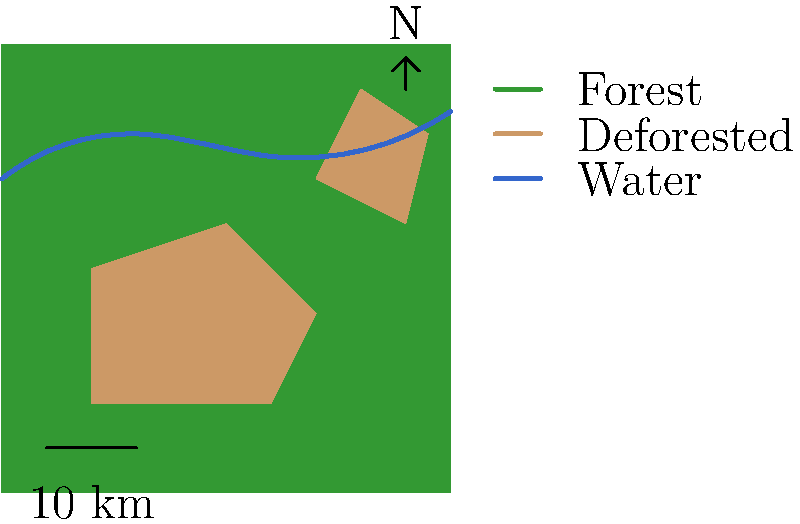Analyze the satellite imagery of a mining-affected region. What percentage of the total land area shown has been deforested due to mining activities? Round your answer to the nearest whole number. To calculate the percentage of deforested land:

1. Estimate the total area of the image:
   The image is approximately a 100x100 unit square, so total area ≈ 10,000 square units.

2. Estimate the deforested areas:
   a. First deforested area (irregular pentagon): ≈ 1,500 square units
   b. Second deforested area (irregular quadrilateral): ≈ 500 square units
   Total deforested area ≈ 2,000 square units

3. Calculate the percentage:
   Percentage = (Deforested area / Total area) × 100
   = (2,000 / 10,000) × 100
   = 0.2 × 100
   = 20%

4. Round to the nearest whole number:
   20% (no rounding needed in this case)

Therefore, approximately 20% of the total land area has been deforested due to mining activities.
Answer: 20% 